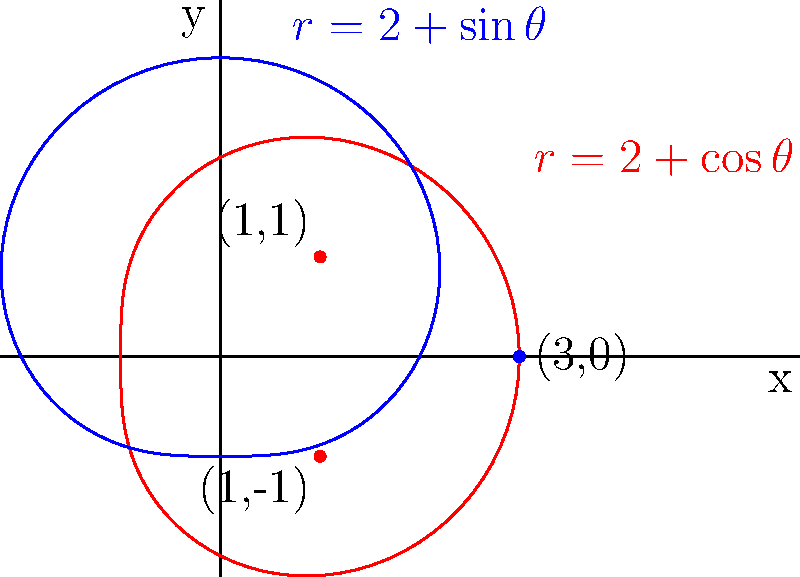In a twist of fate, two polar curves collide to form a witty catchphrase. The red curve is described by $r=2+\cos\theta$ and the blue curve by $r=2+\sin\theta$. How many points of intersection do these curves have, and what clever phrase might they be spelling out? Let's unravel this wordplay step by step:

1) To find the intersection points, we need to solve the equation:
   $2+\cos\theta = 2+\sin\theta$

2) Simplifying:
   $\cos\theta = \sin\theta$

3) This equation is satisfied when $\theta = \frac{\pi}{4}$, $\theta = \frac{5\pi}{4}$, and when $\theta = 0$ (or equivalently, $\theta = 2\pi$).

4) Let's calculate the r-values for these $\theta$:

   For $\theta = \frac{\pi}{4}$:
   $r = 2 + \cos(\frac{\pi}{4}) = 2 + \frac{\sqrt{2}}{2} \approx 2.71$
   This point is at $(1,1)$ in Cartesian coordinates.

   For $\theta = \frac{5\pi}{4}$:
   $r = 2 + \cos(\frac{5\pi}{4}) = 2 - \frac{\sqrt{2}}{2} \approx 1.29$
   This point is at $(1,-1)$ in Cartesian coordinates.

   For $\theta = 0$ or $2\pi$:
   $r = 2 + \cos(0) = 3$
   This point is at $(3,0)$ in Cartesian coordinates.

5) Therefore, the curves intersect at three points: $(1,1)$, $(1,-1)$, and $(3,0)$.

6) Now for the wordplay: These three points form a capital "I" shape. In the context of "witty catchphrase," this could be interpreted as "I" (the personal pronoun), which is often the start of many catchy slogans or phrases.
Answer: 3 points, forming an "I" 